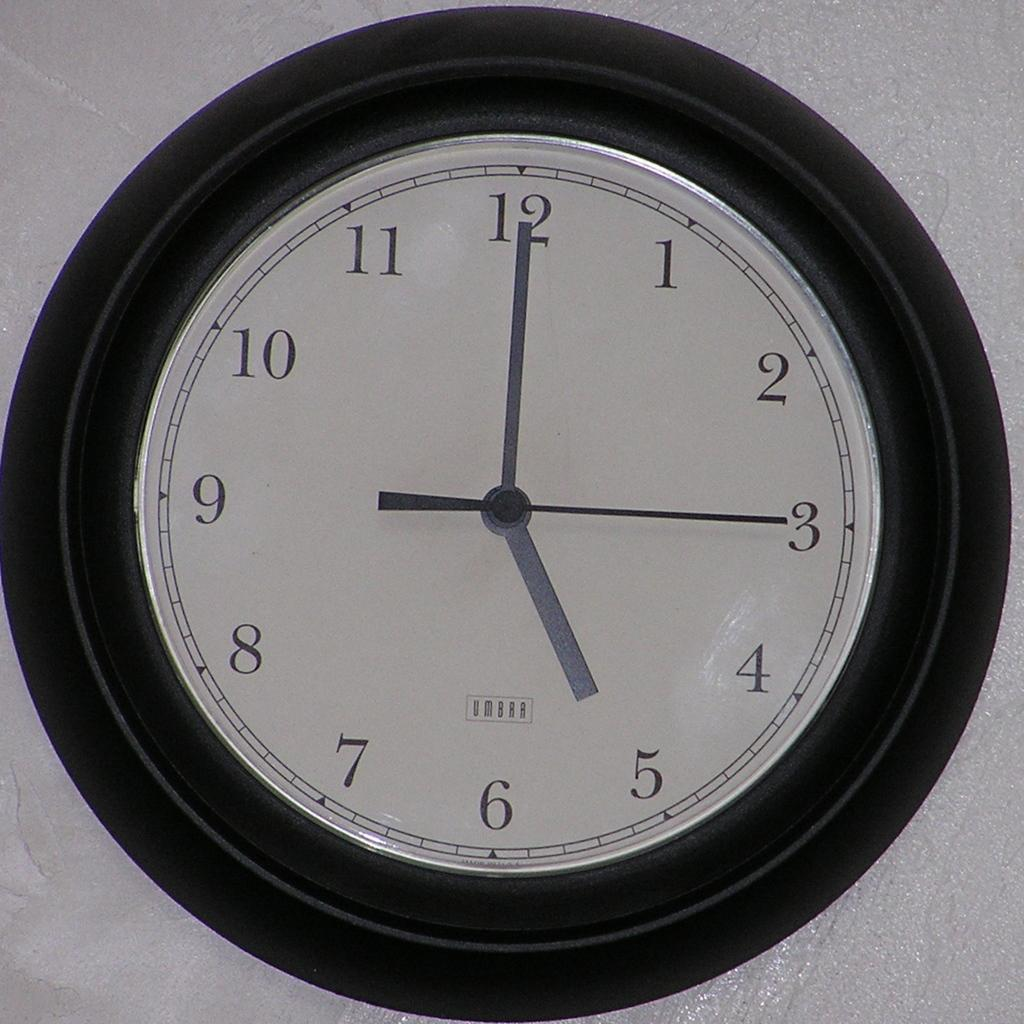<image>
Give a short and clear explanation of the subsequent image. An Umbra wall clcok with the time set to 5:00:15. 